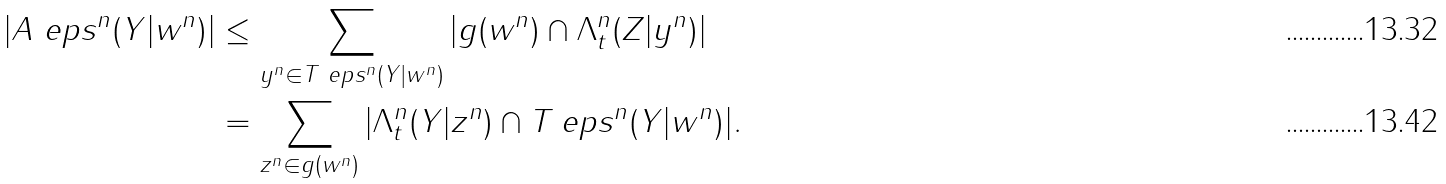<formula> <loc_0><loc_0><loc_500><loc_500>| A _ { \ } e p s ^ { n } ( Y | w ^ { n } ) | & \leq \sum _ { y ^ { n } \in T _ { \ } e p s ^ { n } ( Y | w ^ { n } ) } | g ( w ^ { n } ) \cap \Lambda _ { t } ^ { n } ( Z | y ^ { n } ) | \\ & = \sum _ { z ^ { n } \in g ( w ^ { n } ) } | \Lambda _ { t } ^ { n } ( Y | z ^ { n } ) \cap T _ { \ } e p s ^ { n } ( Y | w ^ { n } ) | .</formula> 